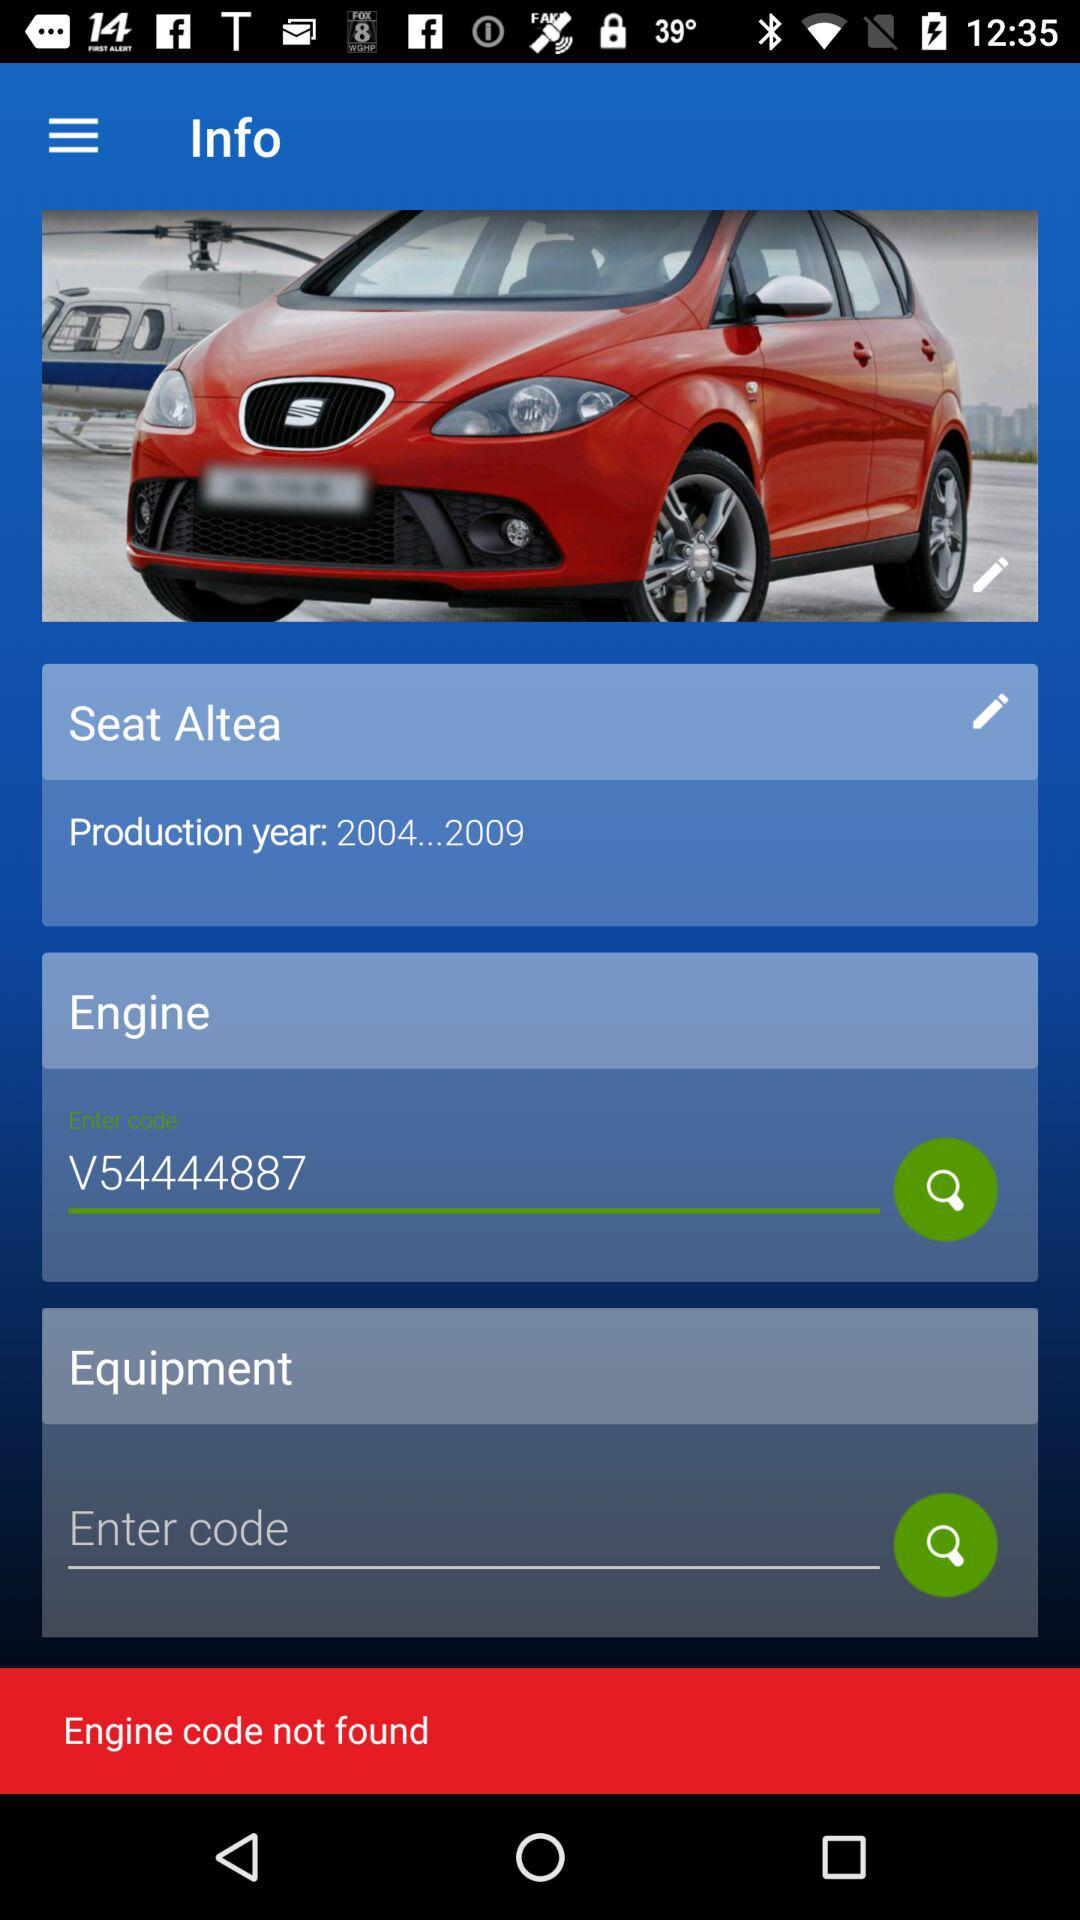How many years was the Seat Altea produced?
Answer the question using a single word or phrase. 2004-2009 